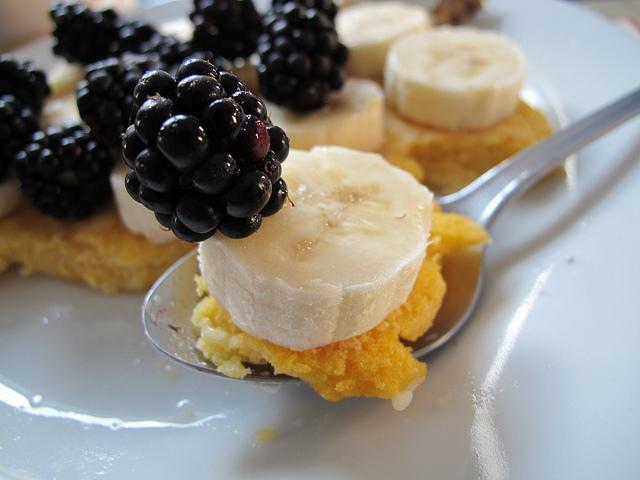How many bananas are there?
Give a very brief answer. 4. 